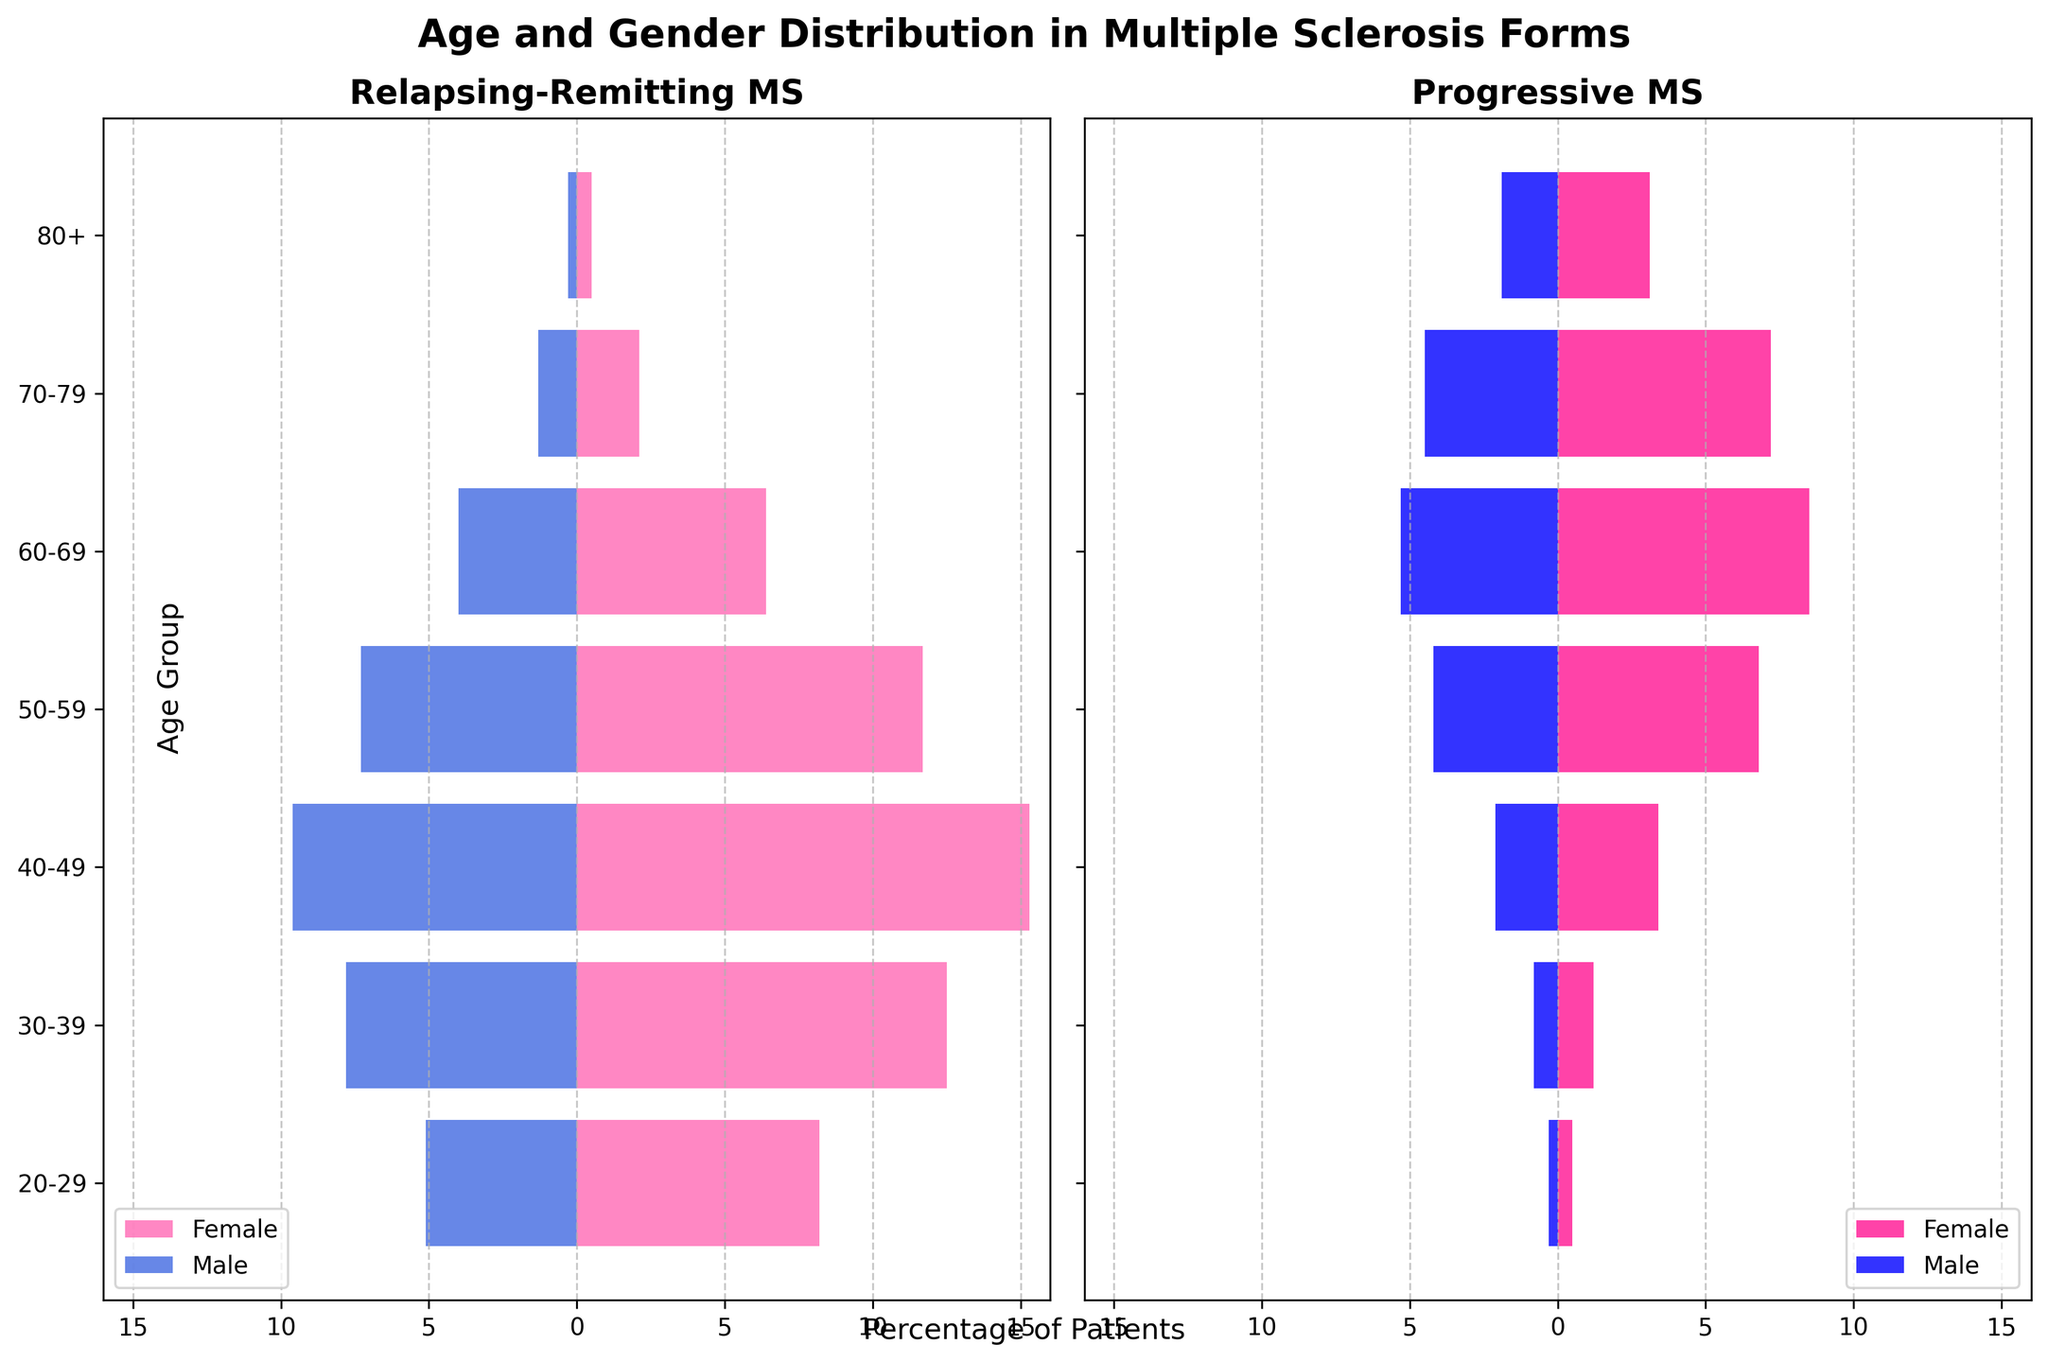What is the title of the figure? The title is usually placed at the top of the chart, often in a larger font size than other text elements. In this figure, the title is centered above the two subplots.
Answer: Age and Gender Distribution in Multiple Sclerosis Forms What are the two subtypes of multiple sclerosis compared in the figure? The titles of the subplots are located above each subplot, clearly indicating the subtypes of multiple sclerosis.
Answer: Relapsing-Remitting MS and Progressive MS Which age group has the highest percentage of females with relapsing-remitting multiple sclerosis? By looking at the left-hand subplot and focusing on the bars extending to the right (representing females), the longest bar corresponds to the 40-49 age group.
Answer: 40-49 For the relapsing-remitting form, which gender has a higher percentage in the 50-59 age group? In the left-hand subplot, compare the length of the female bar extending to the right with the male bar extending to the left for the 50-59 age group.
Answer: Female In the progressive form, which age group has the highest percentage of males? In the right-hand subplot, the longest bar extending to the left (representing males) corresponds to the 60-69 age group.
Answer: 60-69 Which age group has the smallest percentage of patients for both subtypes? By scanning both subplots, it's clear that the 80+ age group has the smallest bars for both relapsing-remitting and progressive MS for both genders.
Answer: 80+ What is the combined percentage of relapsing-remitting males and females for the 30-39 age group? Add the percentage values for relapsing-remitting females (12.5) and males (7.8) in the 30-39 age group.
Answer: 20.3% Are there more progressive females or relapsing-remitting males in the 60-69 age group? Compare the percentage of progressive females (8.5) in the right-hand subplot with relapsing-remitting males (4.0) in the left-hand subplot for the 60-69 age group.
Answer: Progressive females For the age group 70-79, how does the number of relapsing-remitting males compare to progressive females? Compare the length of the bars for relapsing-remitting males (1.3) in the left-hand subplot with that of progressive females (7.2) in the right-hand subplot for the 70-79 age group.
Answer: Relapsing-remitting males are fewer What trend do we observe in the percentage of progressive males and females as age increases? As one moves from the younger to older age groups in the right-hand subplot, the bars for both progressive males and females generally increase in length, indicating a rising percentage with increasing age.
Answer: The percentage increases with age 